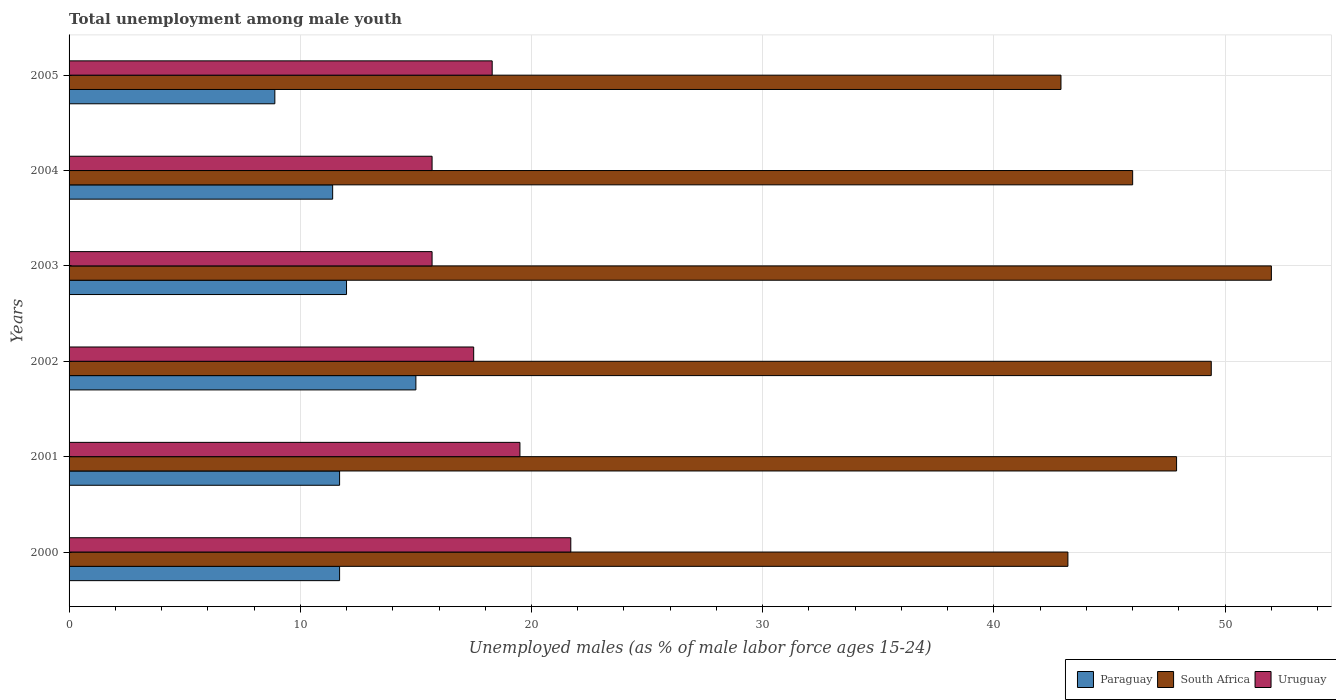How many groups of bars are there?
Ensure brevity in your answer.  6. Are the number of bars on each tick of the Y-axis equal?
Give a very brief answer. Yes. How many bars are there on the 4th tick from the bottom?
Your answer should be compact. 3. Across all years, what is the minimum percentage of unemployed males in in South Africa?
Provide a succinct answer. 42.9. In which year was the percentage of unemployed males in in Paraguay minimum?
Keep it short and to the point. 2005. What is the total percentage of unemployed males in in Uruguay in the graph?
Offer a very short reply. 108.4. What is the difference between the percentage of unemployed males in in Paraguay in 2000 and that in 2005?
Offer a very short reply. 2.8. What is the difference between the percentage of unemployed males in in Uruguay in 2004 and the percentage of unemployed males in in Paraguay in 2003?
Make the answer very short. 3.7. What is the average percentage of unemployed males in in Paraguay per year?
Offer a terse response. 11.78. In the year 2004, what is the difference between the percentage of unemployed males in in Uruguay and percentage of unemployed males in in South Africa?
Offer a very short reply. -30.3. In how many years, is the percentage of unemployed males in in Paraguay greater than 18 %?
Give a very brief answer. 0. What is the ratio of the percentage of unemployed males in in Paraguay in 2000 to that in 2004?
Offer a terse response. 1.03. Is the percentage of unemployed males in in Paraguay in 2000 less than that in 2003?
Your answer should be compact. Yes. What is the difference between the highest and the lowest percentage of unemployed males in in Uruguay?
Give a very brief answer. 6. In how many years, is the percentage of unemployed males in in South Africa greater than the average percentage of unemployed males in in South Africa taken over all years?
Make the answer very short. 3. What does the 2nd bar from the top in 2000 represents?
Offer a terse response. South Africa. What does the 2nd bar from the bottom in 2005 represents?
Provide a short and direct response. South Africa. How many bars are there?
Ensure brevity in your answer.  18. Are all the bars in the graph horizontal?
Your answer should be very brief. Yes. How many years are there in the graph?
Your response must be concise. 6. What is the difference between two consecutive major ticks on the X-axis?
Your answer should be compact. 10. Are the values on the major ticks of X-axis written in scientific E-notation?
Your answer should be very brief. No. Does the graph contain any zero values?
Offer a terse response. No. What is the title of the graph?
Make the answer very short. Total unemployment among male youth. Does "United Kingdom" appear as one of the legend labels in the graph?
Your response must be concise. No. What is the label or title of the X-axis?
Your answer should be very brief. Unemployed males (as % of male labor force ages 15-24). What is the label or title of the Y-axis?
Give a very brief answer. Years. What is the Unemployed males (as % of male labor force ages 15-24) of Paraguay in 2000?
Provide a short and direct response. 11.7. What is the Unemployed males (as % of male labor force ages 15-24) of South Africa in 2000?
Offer a terse response. 43.2. What is the Unemployed males (as % of male labor force ages 15-24) in Uruguay in 2000?
Make the answer very short. 21.7. What is the Unemployed males (as % of male labor force ages 15-24) in Paraguay in 2001?
Provide a short and direct response. 11.7. What is the Unemployed males (as % of male labor force ages 15-24) of South Africa in 2001?
Your response must be concise. 47.9. What is the Unemployed males (as % of male labor force ages 15-24) in Paraguay in 2002?
Your answer should be compact. 15. What is the Unemployed males (as % of male labor force ages 15-24) in South Africa in 2002?
Your answer should be very brief. 49.4. What is the Unemployed males (as % of male labor force ages 15-24) of Paraguay in 2003?
Your response must be concise. 12. What is the Unemployed males (as % of male labor force ages 15-24) in Uruguay in 2003?
Your response must be concise. 15.7. What is the Unemployed males (as % of male labor force ages 15-24) in Paraguay in 2004?
Offer a terse response. 11.4. What is the Unemployed males (as % of male labor force ages 15-24) in Uruguay in 2004?
Provide a short and direct response. 15.7. What is the Unemployed males (as % of male labor force ages 15-24) of Paraguay in 2005?
Offer a terse response. 8.9. What is the Unemployed males (as % of male labor force ages 15-24) of South Africa in 2005?
Your answer should be compact. 42.9. What is the Unemployed males (as % of male labor force ages 15-24) of Uruguay in 2005?
Offer a very short reply. 18.3. Across all years, what is the maximum Unemployed males (as % of male labor force ages 15-24) in Paraguay?
Ensure brevity in your answer.  15. Across all years, what is the maximum Unemployed males (as % of male labor force ages 15-24) of South Africa?
Provide a short and direct response. 52. Across all years, what is the maximum Unemployed males (as % of male labor force ages 15-24) of Uruguay?
Your response must be concise. 21.7. Across all years, what is the minimum Unemployed males (as % of male labor force ages 15-24) in Paraguay?
Offer a very short reply. 8.9. Across all years, what is the minimum Unemployed males (as % of male labor force ages 15-24) in South Africa?
Provide a succinct answer. 42.9. Across all years, what is the minimum Unemployed males (as % of male labor force ages 15-24) of Uruguay?
Offer a terse response. 15.7. What is the total Unemployed males (as % of male labor force ages 15-24) of Paraguay in the graph?
Provide a short and direct response. 70.7. What is the total Unemployed males (as % of male labor force ages 15-24) of South Africa in the graph?
Your response must be concise. 281.4. What is the total Unemployed males (as % of male labor force ages 15-24) of Uruguay in the graph?
Make the answer very short. 108.4. What is the difference between the Unemployed males (as % of male labor force ages 15-24) in Paraguay in 2000 and that in 2001?
Your response must be concise. 0. What is the difference between the Unemployed males (as % of male labor force ages 15-24) in Uruguay in 2000 and that in 2001?
Offer a terse response. 2.2. What is the difference between the Unemployed males (as % of male labor force ages 15-24) of South Africa in 2000 and that in 2002?
Ensure brevity in your answer.  -6.2. What is the difference between the Unemployed males (as % of male labor force ages 15-24) in Uruguay in 2000 and that in 2002?
Give a very brief answer. 4.2. What is the difference between the Unemployed males (as % of male labor force ages 15-24) of South Africa in 2000 and that in 2003?
Provide a short and direct response. -8.8. What is the difference between the Unemployed males (as % of male labor force ages 15-24) in Uruguay in 2000 and that in 2003?
Provide a succinct answer. 6. What is the difference between the Unemployed males (as % of male labor force ages 15-24) in Paraguay in 2000 and that in 2004?
Give a very brief answer. 0.3. What is the difference between the Unemployed males (as % of male labor force ages 15-24) in South Africa in 2000 and that in 2004?
Make the answer very short. -2.8. What is the difference between the Unemployed males (as % of male labor force ages 15-24) in Uruguay in 2000 and that in 2005?
Your answer should be compact. 3.4. What is the difference between the Unemployed males (as % of male labor force ages 15-24) in Uruguay in 2001 and that in 2002?
Your answer should be very brief. 2. What is the difference between the Unemployed males (as % of male labor force ages 15-24) of Paraguay in 2001 and that in 2003?
Provide a succinct answer. -0.3. What is the difference between the Unemployed males (as % of male labor force ages 15-24) in South Africa in 2001 and that in 2003?
Your answer should be very brief. -4.1. What is the difference between the Unemployed males (as % of male labor force ages 15-24) of Uruguay in 2001 and that in 2003?
Provide a succinct answer. 3.8. What is the difference between the Unemployed males (as % of male labor force ages 15-24) of Paraguay in 2001 and that in 2004?
Make the answer very short. 0.3. What is the difference between the Unemployed males (as % of male labor force ages 15-24) in South Africa in 2001 and that in 2004?
Your response must be concise. 1.9. What is the difference between the Unemployed males (as % of male labor force ages 15-24) in Uruguay in 2001 and that in 2004?
Your answer should be compact. 3.8. What is the difference between the Unemployed males (as % of male labor force ages 15-24) of Uruguay in 2001 and that in 2005?
Offer a terse response. 1.2. What is the difference between the Unemployed males (as % of male labor force ages 15-24) in South Africa in 2002 and that in 2003?
Provide a succinct answer. -2.6. What is the difference between the Unemployed males (as % of male labor force ages 15-24) of Uruguay in 2002 and that in 2003?
Provide a short and direct response. 1.8. What is the difference between the Unemployed males (as % of male labor force ages 15-24) of Uruguay in 2002 and that in 2005?
Your answer should be compact. -0.8. What is the difference between the Unemployed males (as % of male labor force ages 15-24) of Paraguay in 2003 and that in 2004?
Make the answer very short. 0.6. What is the difference between the Unemployed males (as % of male labor force ages 15-24) of Uruguay in 2003 and that in 2004?
Your response must be concise. 0. What is the difference between the Unemployed males (as % of male labor force ages 15-24) of South Africa in 2003 and that in 2005?
Keep it short and to the point. 9.1. What is the difference between the Unemployed males (as % of male labor force ages 15-24) of Paraguay in 2004 and that in 2005?
Your answer should be compact. 2.5. What is the difference between the Unemployed males (as % of male labor force ages 15-24) in South Africa in 2004 and that in 2005?
Offer a terse response. 3.1. What is the difference between the Unemployed males (as % of male labor force ages 15-24) of Paraguay in 2000 and the Unemployed males (as % of male labor force ages 15-24) of South Africa in 2001?
Your response must be concise. -36.2. What is the difference between the Unemployed males (as % of male labor force ages 15-24) in South Africa in 2000 and the Unemployed males (as % of male labor force ages 15-24) in Uruguay in 2001?
Give a very brief answer. 23.7. What is the difference between the Unemployed males (as % of male labor force ages 15-24) in Paraguay in 2000 and the Unemployed males (as % of male labor force ages 15-24) in South Africa in 2002?
Your response must be concise. -37.7. What is the difference between the Unemployed males (as % of male labor force ages 15-24) in Paraguay in 2000 and the Unemployed males (as % of male labor force ages 15-24) in Uruguay in 2002?
Offer a terse response. -5.8. What is the difference between the Unemployed males (as % of male labor force ages 15-24) in South Africa in 2000 and the Unemployed males (as % of male labor force ages 15-24) in Uruguay in 2002?
Offer a terse response. 25.7. What is the difference between the Unemployed males (as % of male labor force ages 15-24) in Paraguay in 2000 and the Unemployed males (as % of male labor force ages 15-24) in South Africa in 2003?
Your response must be concise. -40.3. What is the difference between the Unemployed males (as % of male labor force ages 15-24) in Paraguay in 2000 and the Unemployed males (as % of male labor force ages 15-24) in South Africa in 2004?
Offer a terse response. -34.3. What is the difference between the Unemployed males (as % of male labor force ages 15-24) in Paraguay in 2000 and the Unemployed males (as % of male labor force ages 15-24) in South Africa in 2005?
Provide a short and direct response. -31.2. What is the difference between the Unemployed males (as % of male labor force ages 15-24) of South Africa in 2000 and the Unemployed males (as % of male labor force ages 15-24) of Uruguay in 2005?
Offer a very short reply. 24.9. What is the difference between the Unemployed males (as % of male labor force ages 15-24) in Paraguay in 2001 and the Unemployed males (as % of male labor force ages 15-24) in South Africa in 2002?
Ensure brevity in your answer.  -37.7. What is the difference between the Unemployed males (as % of male labor force ages 15-24) of South Africa in 2001 and the Unemployed males (as % of male labor force ages 15-24) of Uruguay in 2002?
Ensure brevity in your answer.  30.4. What is the difference between the Unemployed males (as % of male labor force ages 15-24) in Paraguay in 2001 and the Unemployed males (as % of male labor force ages 15-24) in South Africa in 2003?
Give a very brief answer. -40.3. What is the difference between the Unemployed males (as % of male labor force ages 15-24) of Paraguay in 2001 and the Unemployed males (as % of male labor force ages 15-24) of Uruguay in 2003?
Your response must be concise. -4. What is the difference between the Unemployed males (as % of male labor force ages 15-24) of South Africa in 2001 and the Unemployed males (as % of male labor force ages 15-24) of Uruguay in 2003?
Ensure brevity in your answer.  32.2. What is the difference between the Unemployed males (as % of male labor force ages 15-24) of Paraguay in 2001 and the Unemployed males (as % of male labor force ages 15-24) of South Africa in 2004?
Give a very brief answer. -34.3. What is the difference between the Unemployed males (as % of male labor force ages 15-24) of Paraguay in 2001 and the Unemployed males (as % of male labor force ages 15-24) of Uruguay in 2004?
Offer a very short reply. -4. What is the difference between the Unemployed males (as % of male labor force ages 15-24) of South Africa in 2001 and the Unemployed males (as % of male labor force ages 15-24) of Uruguay in 2004?
Give a very brief answer. 32.2. What is the difference between the Unemployed males (as % of male labor force ages 15-24) in Paraguay in 2001 and the Unemployed males (as % of male labor force ages 15-24) in South Africa in 2005?
Give a very brief answer. -31.2. What is the difference between the Unemployed males (as % of male labor force ages 15-24) in Paraguay in 2001 and the Unemployed males (as % of male labor force ages 15-24) in Uruguay in 2005?
Your answer should be compact. -6.6. What is the difference between the Unemployed males (as % of male labor force ages 15-24) in South Africa in 2001 and the Unemployed males (as % of male labor force ages 15-24) in Uruguay in 2005?
Make the answer very short. 29.6. What is the difference between the Unemployed males (as % of male labor force ages 15-24) in Paraguay in 2002 and the Unemployed males (as % of male labor force ages 15-24) in South Africa in 2003?
Offer a terse response. -37. What is the difference between the Unemployed males (as % of male labor force ages 15-24) in South Africa in 2002 and the Unemployed males (as % of male labor force ages 15-24) in Uruguay in 2003?
Provide a succinct answer. 33.7. What is the difference between the Unemployed males (as % of male labor force ages 15-24) in Paraguay in 2002 and the Unemployed males (as % of male labor force ages 15-24) in South Africa in 2004?
Provide a short and direct response. -31. What is the difference between the Unemployed males (as % of male labor force ages 15-24) in Paraguay in 2002 and the Unemployed males (as % of male labor force ages 15-24) in Uruguay in 2004?
Provide a succinct answer. -0.7. What is the difference between the Unemployed males (as % of male labor force ages 15-24) in South Africa in 2002 and the Unemployed males (as % of male labor force ages 15-24) in Uruguay in 2004?
Make the answer very short. 33.7. What is the difference between the Unemployed males (as % of male labor force ages 15-24) in Paraguay in 2002 and the Unemployed males (as % of male labor force ages 15-24) in South Africa in 2005?
Offer a very short reply. -27.9. What is the difference between the Unemployed males (as % of male labor force ages 15-24) in Paraguay in 2002 and the Unemployed males (as % of male labor force ages 15-24) in Uruguay in 2005?
Offer a very short reply. -3.3. What is the difference between the Unemployed males (as % of male labor force ages 15-24) in South Africa in 2002 and the Unemployed males (as % of male labor force ages 15-24) in Uruguay in 2005?
Provide a short and direct response. 31.1. What is the difference between the Unemployed males (as % of male labor force ages 15-24) of Paraguay in 2003 and the Unemployed males (as % of male labor force ages 15-24) of South Africa in 2004?
Ensure brevity in your answer.  -34. What is the difference between the Unemployed males (as % of male labor force ages 15-24) in Paraguay in 2003 and the Unemployed males (as % of male labor force ages 15-24) in Uruguay in 2004?
Provide a succinct answer. -3.7. What is the difference between the Unemployed males (as % of male labor force ages 15-24) in South Africa in 2003 and the Unemployed males (as % of male labor force ages 15-24) in Uruguay in 2004?
Provide a succinct answer. 36.3. What is the difference between the Unemployed males (as % of male labor force ages 15-24) of Paraguay in 2003 and the Unemployed males (as % of male labor force ages 15-24) of South Africa in 2005?
Give a very brief answer. -30.9. What is the difference between the Unemployed males (as % of male labor force ages 15-24) in South Africa in 2003 and the Unemployed males (as % of male labor force ages 15-24) in Uruguay in 2005?
Provide a short and direct response. 33.7. What is the difference between the Unemployed males (as % of male labor force ages 15-24) of Paraguay in 2004 and the Unemployed males (as % of male labor force ages 15-24) of South Africa in 2005?
Provide a succinct answer. -31.5. What is the difference between the Unemployed males (as % of male labor force ages 15-24) of South Africa in 2004 and the Unemployed males (as % of male labor force ages 15-24) of Uruguay in 2005?
Provide a short and direct response. 27.7. What is the average Unemployed males (as % of male labor force ages 15-24) of Paraguay per year?
Provide a short and direct response. 11.78. What is the average Unemployed males (as % of male labor force ages 15-24) of South Africa per year?
Provide a succinct answer. 46.9. What is the average Unemployed males (as % of male labor force ages 15-24) in Uruguay per year?
Provide a succinct answer. 18.07. In the year 2000, what is the difference between the Unemployed males (as % of male labor force ages 15-24) of Paraguay and Unemployed males (as % of male labor force ages 15-24) of South Africa?
Ensure brevity in your answer.  -31.5. In the year 2000, what is the difference between the Unemployed males (as % of male labor force ages 15-24) of Paraguay and Unemployed males (as % of male labor force ages 15-24) of Uruguay?
Your response must be concise. -10. In the year 2000, what is the difference between the Unemployed males (as % of male labor force ages 15-24) in South Africa and Unemployed males (as % of male labor force ages 15-24) in Uruguay?
Provide a succinct answer. 21.5. In the year 2001, what is the difference between the Unemployed males (as % of male labor force ages 15-24) in Paraguay and Unemployed males (as % of male labor force ages 15-24) in South Africa?
Keep it short and to the point. -36.2. In the year 2001, what is the difference between the Unemployed males (as % of male labor force ages 15-24) in Paraguay and Unemployed males (as % of male labor force ages 15-24) in Uruguay?
Offer a terse response. -7.8. In the year 2001, what is the difference between the Unemployed males (as % of male labor force ages 15-24) in South Africa and Unemployed males (as % of male labor force ages 15-24) in Uruguay?
Your response must be concise. 28.4. In the year 2002, what is the difference between the Unemployed males (as % of male labor force ages 15-24) in Paraguay and Unemployed males (as % of male labor force ages 15-24) in South Africa?
Provide a succinct answer. -34.4. In the year 2002, what is the difference between the Unemployed males (as % of male labor force ages 15-24) of South Africa and Unemployed males (as % of male labor force ages 15-24) of Uruguay?
Keep it short and to the point. 31.9. In the year 2003, what is the difference between the Unemployed males (as % of male labor force ages 15-24) of Paraguay and Unemployed males (as % of male labor force ages 15-24) of Uruguay?
Offer a very short reply. -3.7. In the year 2003, what is the difference between the Unemployed males (as % of male labor force ages 15-24) of South Africa and Unemployed males (as % of male labor force ages 15-24) of Uruguay?
Provide a short and direct response. 36.3. In the year 2004, what is the difference between the Unemployed males (as % of male labor force ages 15-24) in Paraguay and Unemployed males (as % of male labor force ages 15-24) in South Africa?
Your answer should be very brief. -34.6. In the year 2004, what is the difference between the Unemployed males (as % of male labor force ages 15-24) of Paraguay and Unemployed males (as % of male labor force ages 15-24) of Uruguay?
Your answer should be very brief. -4.3. In the year 2004, what is the difference between the Unemployed males (as % of male labor force ages 15-24) in South Africa and Unemployed males (as % of male labor force ages 15-24) in Uruguay?
Offer a very short reply. 30.3. In the year 2005, what is the difference between the Unemployed males (as % of male labor force ages 15-24) of Paraguay and Unemployed males (as % of male labor force ages 15-24) of South Africa?
Your response must be concise. -34. In the year 2005, what is the difference between the Unemployed males (as % of male labor force ages 15-24) of South Africa and Unemployed males (as % of male labor force ages 15-24) of Uruguay?
Your response must be concise. 24.6. What is the ratio of the Unemployed males (as % of male labor force ages 15-24) in South Africa in 2000 to that in 2001?
Offer a terse response. 0.9. What is the ratio of the Unemployed males (as % of male labor force ages 15-24) of Uruguay in 2000 to that in 2001?
Your answer should be compact. 1.11. What is the ratio of the Unemployed males (as % of male labor force ages 15-24) in Paraguay in 2000 to that in 2002?
Offer a terse response. 0.78. What is the ratio of the Unemployed males (as % of male labor force ages 15-24) in South Africa in 2000 to that in 2002?
Keep it short and to the point. 0.87. What is the ratio of the Unemployed males (as % of male labor force ages 15-24) in Uruguay in 2000 to that in 2002?
Make the answer very short. 1.24. What is the ratio of the Unemployed males (as % of male labor force ages 15-24) of Paraguay in 2000 to that in 2003?
Your answer should be compact. 0.97. What is the ratio of the Unemployed males (as % of male labor force ages 15-24) of South Africa in 2000 to that in 2003?
Offer a terse response. 0.83. What is the ratio of the Unemployed males (as % of male labor force ages 15-24) of Uruguay in 2000 to that in 2003?
Provide a succinct answer. 1.38. What is the ratio of the Unemployed males (as % of male labor force ages 15-24) of Paraguay in 2000 to that in 2004?
Provide a succinct answer. 1.03. What is the ratio of the Unemployed males (as % of male labor force ages 15-24) of South Africa in 2000 to that in 2004?
Make the answer very short. 0.94. What is the ratio of the Unemployed males (as % of male labor force ages 15-24) in Uruguay in 2000 to that in 2004?
Provide a short and direct response. 1.38. What is the ratio of the Unemployed males (as % of male labor force ages 15-24) in Paraguay in 2000 to that in 2005?
Make the answer very short. 1.31. What is the ratio of the Unemployed males (as % of male labor force ages 15-24) of Uruguay in 2000 to that in 2005?
Keep it short and to the point. 1.19. What is the ratio of the Unemployed males (as % of male labor force ages 15-24) of Paraguay in 2001 to that in 2002?
Your answer should be very brief. 0.78. What is the ratio of the Unemployed males (as % of male labor force ages 15-24) in South Africa in 2001 to that in 2002?
Your answer should be very brief. 0.97. What is the ratio of the Unemployed males (as % of male labor force ages 15-24) in Uruguay in 2001 to that in 2002?
Offer a terse response. 1.11. What is the ratio of the Unemployed males (as % of male labor force ages 15-24) in Paraguay in 2001 to that in 2003?
Offer a terse response. 0.97. What is the ratio of the Unemployed males (as % of male labor force ages 15-24) in South Africa in 2001 to that in 2003?
Make the answer very short. 0.92. What is the ratio of the Unemployed males (as % of male labor force ages 15-24) of Uruguay in 2001 to that in 2003?
Your answer should be compact. 1.24. What is the ratio of the Unemployed males (as % of male labor force ages 15-24) in Paraguay in 2001 to that in 2004?
Your answer should be very brief. 1.03. What is the ratio of the Unemployed males (as % of male labor force ages 15-24) in South Africa in 2001 to that in 2004?
Provide a short and direct response. 1.04. What is the ratio of the Unemployed males (as % of male labor force ages 15-24) of Uruguay in 2001 to that in 2004?
Your answer should be compact. 1.24. What is the ratio of the Unemployed males (as % of male labor force ages 15-24) of Paraguay in 2001 to that in 2005?
Your answer should be very brief. 1.31. What is the ratio of the Unemployed males (as % of male labor force ages 15-24) of South Africa in 2001 to that in 2005?
Your response must be concise. 1.12. What is the ratio of the Unemployed males (as % of male labor force ages 15-24) in Uruguay in 2001 to that in 2005?
Give a very brief answer. 1.07. What is the ratio of the Unemployed males (as % of male labor force ages 15-24) of South Africa in 2002 to that in 2003?
Ensure brevity in your answer.  0.95. What is the ratio of the Unemployed males (as % of male labor force ages 15-24) of Uruguay in 2002 to that in 2003?
Keep it short and to the point. 1.11. What is the ratio of the Unemployed males (as % of male labor force ages 15-24) of Paraguay in 2002 to that in 2004?
Keep it short and to the point. 1.32. What is the ratio of the Unemployed males (as % of male labor force ages 15-24) in South Africa in 2002 to that in 2004?
Make the answer very short. 1.07. What is the ratio of the Unemployed males (as % of male labor force ages 15-24) in Uruguay in 2002 to that in 2004?
Your response must be concise. 1.11. What is the ratio of the Unemployed males (as % of male labor force ages 15-24) of Paraguay in 2002 to that in 2005?
Offer a terse response. 1.69. What is the ratio of the Unemployed males (as % of male labor force ages 15-24) of South Africa in 2002 to that in 2005?
Provide a short and direct response. 1.15. What is the ratio of the Unemployed males (as % of male labor force ages 15-24) in Uruguay in 2002 to that in 2005?
Offer a terse response. 0.96. What is the ratio of the Unemployed males (as % of male labor force ages 15-24) in Paraguay in 2003 to that in 2004?
Keep it short and to the point. 1.05. What is the ratio of the Unemployed males (as % of male labor force ages 15-24) in South Africa in 2003 to that in 2004?
Keep it short and to the point. 1.13. What is the ratio of the Unemployed males (as % of male labor force ages 15-24) of Uruguay in 2003 to that in 2004?
Offer a terse response. 1. What is the ratio of the Unemployed males (as % of male labor force ages 15-24) in Paraguay in 2003 to that in 2005?
Keep it short and to the point. 1.35. What is the ratio of the Unemployed males (as % of male labor force ages 15-24) of South Africa in 2003 to that in 2005?
Your response must be concise. 1.21. What is the ratio of the Unemployed males (as % of male labor force ages 15-24) in Uruguay in 2003 to that in 2005?
Provide a short and direct response. 0.86. What is the ratio of the Unemployed males (as % of male labor force ages 15-24) of Paraguay in 2004 to that in 2005?
Ensure brevity in your answer.  1.28. What is the ratio of the Unemployed males (as % of male labor force ages 15-24) in South Africa in 2004 to that in 2005?
Make the answer very short. 1.07. What is the ratio of the Unemployed males (as % of male labor force ages 15-24) in Uruguay in 2004 to that in 2005?
Provide a short and direct response. 0.86. What is the difference between the highest and the lowest Unemployed males (as % of male labor force ages 15-24) of Paraguay?
Give a very brief answer. 6.1. What is the difference between the highest and the lowest Unemployed males (as % of male labor force ages 15-24) in South Africa?
Keep it short and to the point. 9.1. What is the difference between the highest and the lowest Unemployed males (as % of male labor force ages 15-24) in Uruguay?
Offer a terse response. 6. 